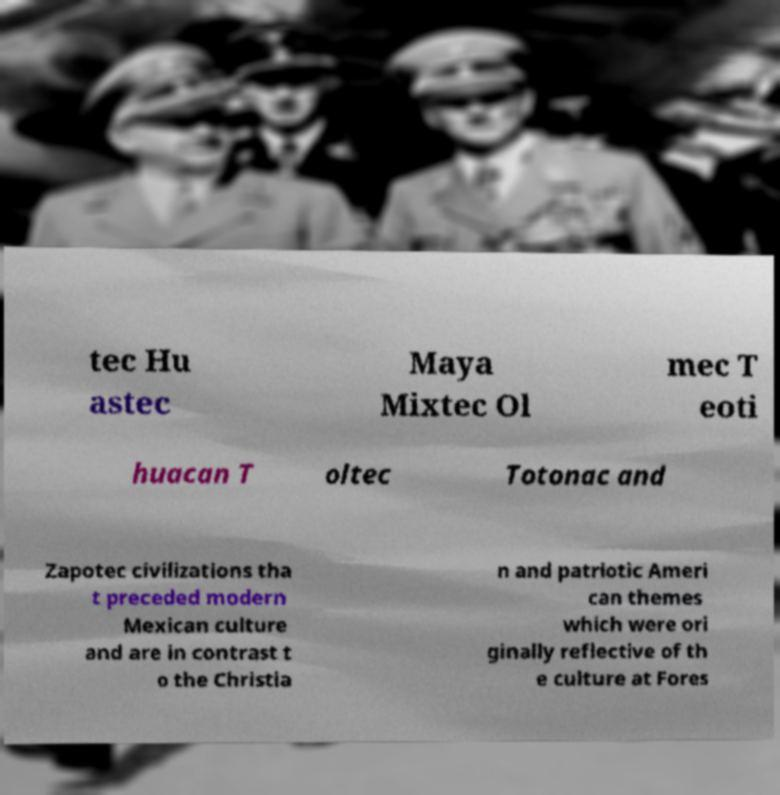Can you read and provide the text displayed in the image?This photo seems to have some interesting text. Can you extract and type it out for me? tec Hu astec Maya Mixtec Ol mec T eoti huacan T oltec Totonac and Zapotec civilizations tha t preceded modern Mexican culture and are in contrast t o the Christia n and patriotic Ameri can themes which were ori ginally reflective of th e culture at Fores 